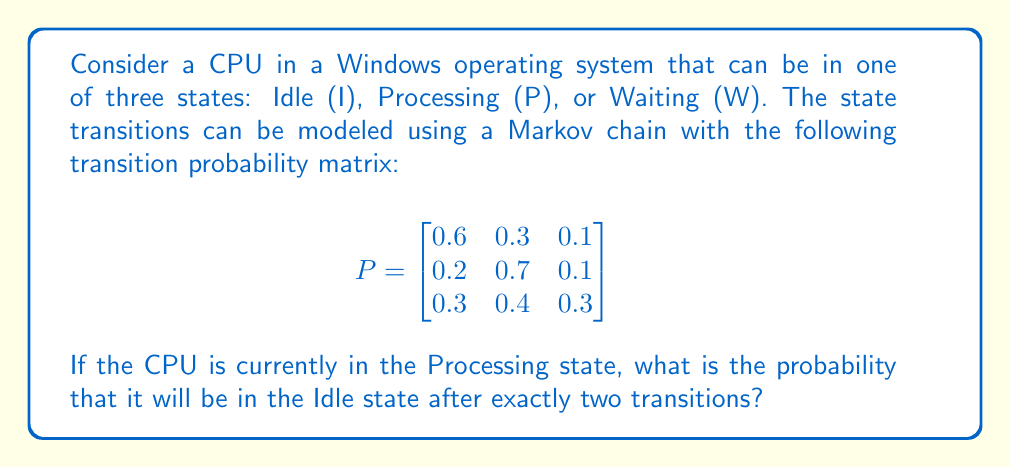Solve this math problem. To solve this problem, we need to use the Chapman-Kolmogorov equations and matrix multiplication. Let's break it down step-by-step:

1. We start in the Processing state, which is represented by the initial probability vector:
   $$v_0 = \begin{bmatrix} 0 & 1 & 0 \end{bmatrix}$$

2. To find the state after two transitions, we need to multiply the initial vector by the transition matrix twice:
   $$v_2 = v_0 \cdot P^2$$

3. Let's calculate $P^2$:
   $$P^2 = P \cdot P = \begin{bmatrix}
   0.6 & 0.3 & 0.1 \\
   0.2 & 0.7 & 0.1 \\
   0.3 & 0.4 & 0.3
   \end{bmatrix} \cdot \begin{bmatrix}
   0.6 & 0.3 & 0.1 \\
   0.2 & 0.7 & 0.1 \\
   0.3 & 0.4 & 0.3
   \end{bmatrix}$$

4. Performing the matrix multiplication:
   $$P^2 = \begin{bmatrix}
   0.45 & 0.43 & 0.12 \\
   0.31 & 0.58 & 0.11 \\
   0.39 & 0.46 & 0.15
   \end{bmatrix}$$

5. Now, we multiply the initial vector $v_0$ by $P^2$:
   $$v_2 = \begin{bmatrix} 0 & 1 & 0 \end{bmatrix} \cdot \begin{bmatrix}
   0.45 & 0.43 & 0.12 \\
   0.31 & 0.58 & 0.11 \\
   0.39 & 0.46 & 0.15
   \end{bmatrix}$$

6. This multiplication selects the second row of $P^2$:
   $$v_2 = \begin{bmatrix} 0.31 & 0.58 & 0.11 \end{bmatrix}$$

7. The probability of being in the Idle state (first element) after two transitions is 0.31 or 31%.
Answer: 0.31 